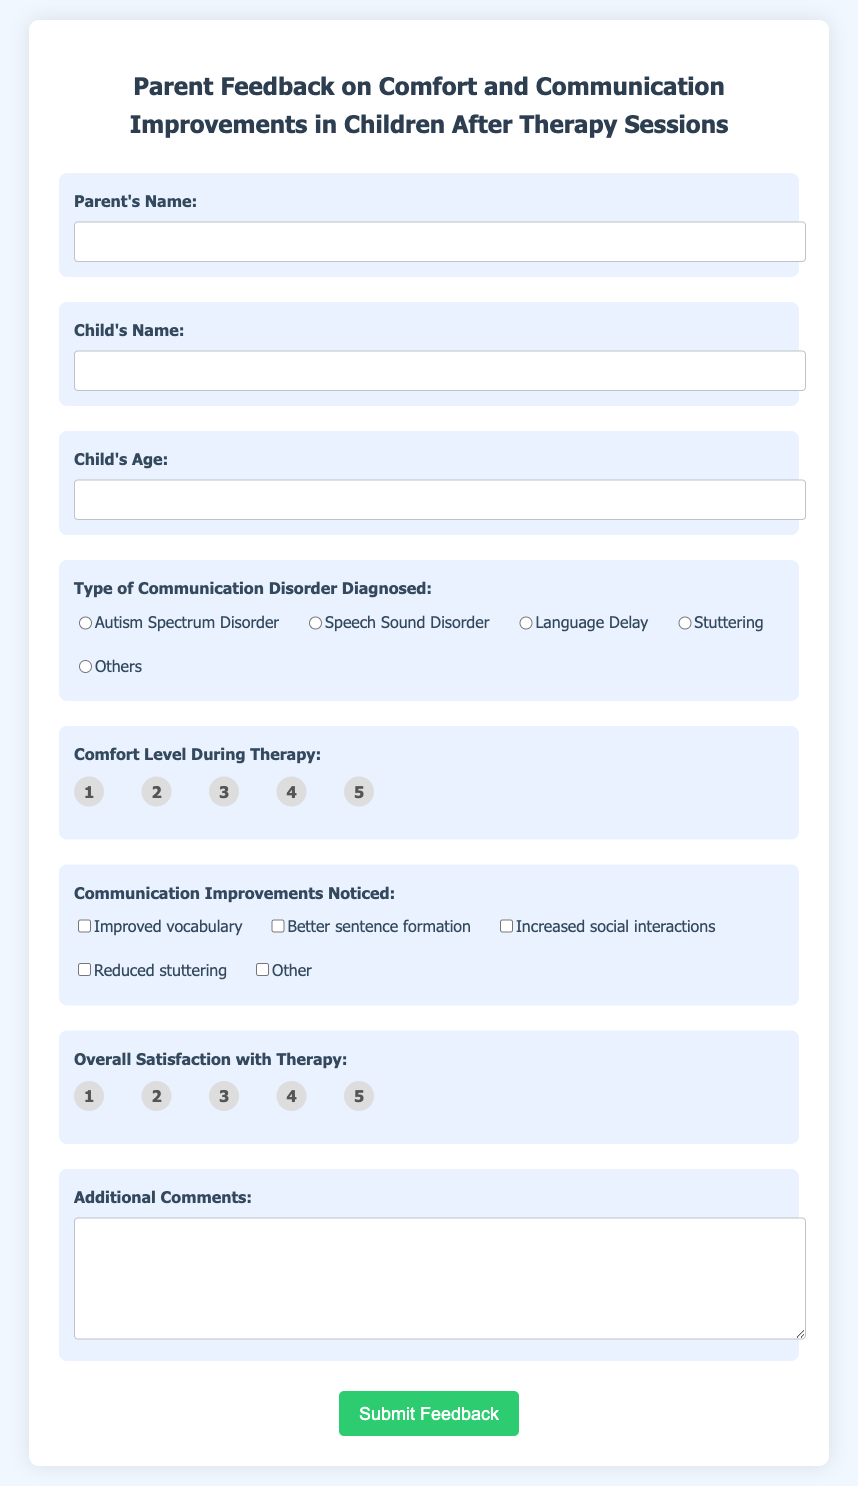What is the title of the document? The title of the document is displayed prominently at the top of the form.
Answer: Parent Feedback on Comfort and Communication Improvements in Children After Therapy Sessions What input is required for the parent's name? The document specifies that the parent's name must be entered, and this is indicated as a required field.
Answer: Text input What is the maximum age allowed for the child? The age field specifies a maximum age limit, which is indicated with a maximum attribute in the input box.
Answer: 18 Which types of communication disorders are listed? The document provides a selection of communication disorders as options for the parent to choose from.
Answer: Autism Spectrum Disorder, Speech Sound Disorder, Language Delay, Stuttering, Others What are the rating options for comfort level during therapy? The document includes a set of radio buttons representing a scale for comfort level, ranging from one to five.
Answer: 1 to 5 What additional feedback can parents provide? The document provides a text area for any additional comments, allowing for open-ended responses.
Answer: Additional Comments How many options are available for communication improvements? The document lists several checkboxes for the parent to select any communication improvements they've noticed.
Answer: Five options What is the purpose of the submit button? The submit button is designed for the user to complete the feedback form and send their responses.
Answer: Submit Feedback 